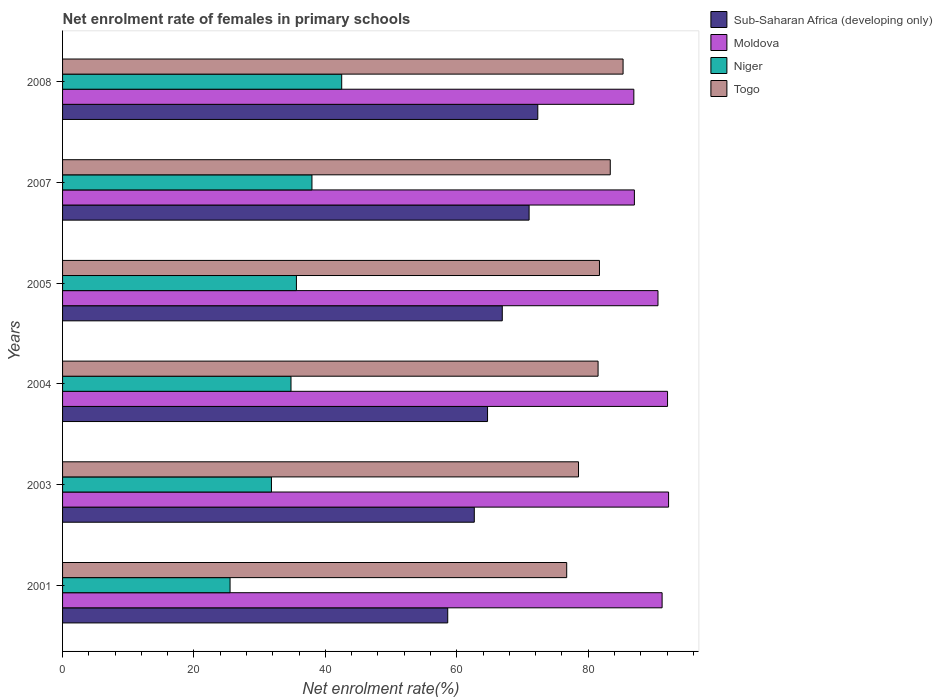How many different coloured bars are there?
Your answer should be compact. 4. Are the number of bars per tick equal to the number of legend labels?
Ensure brevity in your answer.  Yes. How many bars are there on the 1st tick from the bottom?
Your answer should be very brief. 4. In how many cases, is the number of bars for a given year not equal to the number of legend labels?
Offer a very short reply. 0. What is the net enrolment rate of females in primary schools in Togo in 2003?
Offer a terse response. 78.53. Across all years, what is the maximum net enrolment rate of females in primary schools in Togo?
Offer a very short reply. 85.31. Across all years, what is the minimum net enrolment rate of females in primary schools in Niger?
Keep it short and to the point. 25.49. In which year was the net enrolment rate of females in primary schools in Niger minimum?
Your answer should be compact. 2001. What is the total net enrolment rate of females in primary schools in Sub-Saharan Africa (developing only) in the graph?
Provide a succinct answer. 396.22. What is the difference between the net enrolment rate of females in primary schools in Sub-Saharan Africa (developing only) in 2003 and that in 2007?
Your answer should be very brief. -8.34. What is the difference between the net enrolment rate of females in primary schools in Moldova in 2004 and the net enrolment rate of females in primary schools in Togo in 2005?
Provide a short and direct response. 10.36. What is the average net enrolment rate of females in primary schools in Niger per year?
Your response must be concise. 34.68. In the year 2003, what is the difference between the net enrolment rate of females in primary schools in Moldova and net enrolment rate of females in primary schools in Niger?
Your response must be concise. 60.44. What is the ratio of the net enrolment rate of females in primary schools in Niger in 2001 to that in 2003?
Provide a short and direct response. 0.8. Is the net enrolment rate of females in primary schools in Moldova in 2001 less than that in 2008?
Offer a very short reply. No. What is the difference between the highest and the second highest net enrolment rate of females in primary schools in Togo?
Offer a terse response. 1.95. What is the difference between the highest and the lowest net enrolment rate of females in primary schools in Moldova?
Keep it short and to the point. 5.29. Is it the case that in every year, the sum of the net enrolment rate of females in primary schools in Togo and net enrolment rate of females in primary schools in Moldova is greater than the sum of net enrolment rate of females in primary schools in Sub-Saharan Africa (developing only) and net enrolment rate of females in primary schools in Niger?
Offer a terse response. Yes. What does the 2nd bar from the top in 2008 represents?
Ensure brevity in your answer.  Niger. What does the 4th bar from the bottom in 2004 represents?
Offer a very short reply. Togo. How many bars are there?
Your response must be concise. 24. What is the difference between two consecutive major ticks on the X-axis?
Keep it short and to the point. 20. What is the title of the graph?
Your answer should be compact. Net enrolment rate of females in primary schools. Does "Puerto Rico" appear as one of the legend labels in the graph?
Your answer should be very brief. No. What is the label or title of the X-axis?
Your answer should be compact. Net enrolment rate(%). What is the Net enrolment rate(%) in Sub-Saharan Africa (developing only) in 2001?
Your answer should be compact. 58.62. What is the Net enrolment rate(%) of Moldova in 2001?
Your response must be concise. 91.25. What is the Net enrolment rate(%) in Niger in 2001?
Ensure brevity in your answer.  25.49. What is the Net enrolment rate(%) in Togo in 2001?
Offer a very short reply. 76.73. What is the Net enrolment rate(%) of Sub-Saharan Africa (developing only) in 2003?
Your response must be concise. 62.66. What is the Net enrolment rate(%) of Moldova in 2003?
Ensure brevity in your answer.  92.23. What is the Net enrolment rate(%) of Niger in 2003?
Give a very brief answer. 31.79. What is the Net enrolment rate(%) of Togo in 2003?
Offer a terse response. 78.53. What is the Net enrolment rate(%) in Sub-Saharan Africa (developing only) in 2004?
Your response must be concise. 64.68. What is the Net enrolment rate(%) of Moldova in 2004?
Keep it short and to the point. 92.08. What is the Net enrolment rate(%) of Niger in 2004?
Keep it short and to the point. 34.77. What is the Net enrolment rate(%) in Togo in 2004?
Provide a succinct answer. 81.5. What is the Net enrolment rate(%) in Sub-Saharan Africa (developing only) in 2005?
Provide a short and direct response. 66.92. What is the Net enrolment rate(%) in Moldova in 2005?
Your answer should be very brief. 90.62. What is the Net enrolment rate(%) of Niger in 2005?
Keep it short and to the point. 35.59. What is the Net enrolment rate(%) in Togo in 2005?
Your answer should be compact. 81.71. What is the Net enrolment rate(%) in Sub-Saharan Africa (developing only) in 2007?
Give a very brief answer. 71.01. What is the Net enrolment rate(%) of Moldova in 2007?
Offer a terse response. 87.03. What is the Net enrolment rate(%) in Niger in 2007?
Your answer should be very brief. 37.96. What is the Net enrolment rate(%) of Togo in 2007?
Provide a short and direct response. 83.36. What is the Net enrolment rate(%) of Sub-Saharan Africa (developing only) in 2008?
Provide a short and direct response. 72.33. What is the Net enrolment rate(%) in Moldova in 2008?
Provide a succinct answer. 86.95. What is the Net enrolment rate(%) of Niger in 2008?
Your response must be concise. 42.48. What is the Net enrolment rate(%) in Togo in 2008?
Provide a succinct answer. 85.31. Across all years, what is the maximum Net enrolment rate(%) in Sub-Saharan Africa (developing only)?
Your answer should be compact. 72.33. Across all years, what is the maximum Net enrolment rate(%) of Moldova?
Ensure brevity in your answer.  92.23. Across all years, what is the maximum Net enrolment rate(%) of Niger?
Make the answer very short. 42.48. Across all years, what is the maximum Net enrolment rate(%) of Togo?
Offer a very short reply. 85.31. Across all years, what is the minimum Net enrolment rate(%) in Sub-Saharan Africa (developing only)?
Your answer should be compact. 58.62. Across all years, what is the minimum Net enrolment rate(%) in Moldova?
Offer a terse response. 86.95. Across all years, what is the minimum Net enrolment rate(%) in Niger?
Provide a succinct answer. 25.49. Across all years, what is the minimum Net enrolment rate(%) of Togo?
Offer a terse response. 76.73. What is the total Net enrolment rate(%) in Sub-Saharan Africa (developing only) in the graph?
Provide a succinct answer. 396.22. What is the total Net enrolment rate(%) of Moldova in the graph?
Offer a very short reply. 540.16. What is the total Net enrolment rate(%) of Niger in the graph?
Offer a terse response. 208.08. What is the total Net enrolment rate(%) in Togo in the graph?
Make the answer very short. 487.14. What is the difference between the Net enrolment rate(%) of Sub-Saharan Africa (developing only) in 2001 and that in 2003?
Provide a succinct answer. -4.04. What is the difference between the Net enrolment rate(%) in Moldova in 2001 and that in 2003?
Your answer should be very brief. -0.99. What is the difference between the Net enrolment rate(%) of Niger in 2001 and that in 2003?
Make the answer very short. -6.3. What is the difference between the Net enrolment rate(%) of Togo in 2001 and that in 2003?
Offer a terse response. -1.8. What is the difference between the Net enrolment rate(%) in Sub-Saharan Africa (developing only) in 2001 and that in 2004?
Offer a very short reply. -6.06. What is the difference between the Net enrolment rate(%) in Moldova in 2001 and that in 2004?
Keep it short and to the point. -0.83. What is the difference between the Net enrolment rate(%) of Niger in 2001 and that in 2004?
Your answer should be very brief. -9.27. What is the difference between the Net enrolment rate(%) in Togo in 2001 and that in 2004?
Keep it short and to the point. -4.78. What is the difference between the Net enrolment rate(%) in Sub-Saharan Africa (developing only) in 2001 and that in 2005?
Your answer should be compact. -8.3. What is the difference between the Net enrolment rate(%) in Moldova in 2001 and that in 2005?
Keep it short and to the point. 0.63. What is the difference between the Net enrolment rate(%) in Niger in 2001 and that in 2005?
Your answer should be very brief. -10.1. What is the difference between the Net enrolment rate(%) in Togo in 2001 and that in 2005?
Your response must be concise. -4.99. What is the difference between the Net enrolment rate(%) in Sub-Saharan Africa (developing only) in 2001 and that in 2007?
Keep it short and to the point. -12.38. What is the difference between the Net enrolment rate(%) of Moldova in 2001 and that in 2007?
Your answer should be compact. 4.22. What is the difference between the Net enrolment rate(%) of Niger in 2001 and that in 2007?
Offer a very short reply. -12.46. What is the difference between the Net enrolment rate(%) of Togo in 2001 and that in 2007?
Ensure brevity in your answer.  -6.63. What is the difference between the Net enrolment rate(%) of Sub-Saharan Africa (developing only) in 2001 and that in 2008?
Your response must be concise. -13.71. What is the difference between the Net enrolment rate(%) of Moldova in 2001 and that in 2008?
Provide a succinct answer. 4.3. What is the difference between the Net enrolment rate(%) of Niger in 2001 and that in 2008?
Offer a very short reply. -16.99. What is the difference between the Net enrolment rate(%) of Togo in 2001 and that in 2008?
Offer a terse response. -8.58. What is the difference between the Net enrolment rate(%) of Sub-Saharan Africa (developing only) in 2003 and that in 2004?
Offer a very short reply. -2.02. What is the difference between the Net enrolment rate(%) in Moldova in 2003 and that in 2004?
Your response must be concise. 0.16. What is the difference between the Net enrolment rate(%) of Niger in 2003 and that in 2004?
Provide a short and direct response. -2.98. What is the difference between the Net enrolment rate(%) in Togo in 2003 and that in 2004?
Give a very brief answer. -2.98. What is the difference between the Net enrolment rate(%) of Sub-Saharan Africa (developing only) in 2003 and that in 2005?
Offer a very short reply. -4.26. What is the difference between the Net enrolment rate(%) in Moldova in 2003 and that in 2005?
Offer a very short reply. 1.61. What is the difference between the Net enrolment rate(%) in Niger in 2003 and that in 2005?
Your answer should be compact. -3.8. What is the difference between the Net enrolment rate(%) of Togo in 2003 and that in 2005?
Ensure brevity in your answer.  -3.19. What is the difference between the Net enrolment rate(%) in Sub-Saharan Africa (developing only) in 2003 and that in 2007?
Offer a terse response. -8.34. What is the difference between the Net enrolment rate(%) of Moldova in 2003 and that in 2007?
Provide a short and direct response. 5.2. What is the difference between the Net enrolment rate(%) of Niger in 2003 and that in 2007?
Ensure brevity in your answer.  -6.17. What is the difference between the Net enrolment rate(%) of Togo in 2003 and that in 2007?
Ensure brevity in your answer.  -4.83. What is the difference between the Net enrolment rate(%) in Sub-Saharan Africa (developing only) in 2003 and that in 2008?
Make the answer very short. -9.66. What is the difference between the Net enrolment rate(%) in Moldova in 2003 and that in 2008?
Keep it short and to the point. 5.29. What is the difference between the Net enrolment rate(%) of Niger in 2003 and that in 2008?
Your answer should be compact. -10.69. What is the difference between the Net enrolment rate(%) in Togo in 2003 and that in 2008?
Make the answer very short. -6.78. What is the difference between the Net enrolment rate(%) in Sub-Saharan Africa (developing only) in 2004 and that in 2005?
Offer a very short reply. -2.24. What is the difference between the Net enrolment rate(%) in Moldova in 2004 and that in 2005?
Your answer should be compact. 1.45. What is the difference between the Net enrolment rate(%) of Niger in 2004 and that in 2005?
Your answer should be very brief. -0.82. What is the difference between the Net enrolment rate(%) in Togo in 2004 and that in 2005?
Offer a very short reply. -0.21. What is the difference between the Net enrolment rate(%) of Sub-Saharan Africa (developing only) in 2004 and that in 2007?
Ensure brevity in your answer.  -6.33. What is the difference between the Net enrolment rate(%) in Moldova in 2004 and that in 2007?
Keep it short and to the point. 5.05. What is the difference between the Net enrolment rate(%) of Niger in 2004 and that in 2007?
Make the answer very short. -3.19. What is the difference between the Net enrolment rate(%) of Togo in 2004 and that in 2007?
Make the answer very short. -1.85. What is the difference between the Net enrolment rate(%) of Sub-Saharan Africa (developing only) in 2004 and that in 2008?
Your answer should be compact. -7.65. What is the difference between the Net enrolment rate(%) in Moldova in 2004 and that in 2008?
Ensure brevity in your answer.  5.13. What is the difference between the Net enrolment rate(%) in Niger in 2004 and that in 2008?
Provide a short and direct response. -7.72. What is the difference between the Net enrolment rate(%) of Togo in 2004 and that in 2008?
Keep it short and to the point. -3.8. What is the difference between the Net enrolment rate(%) of Sub-Saharan Africa (developing only) in 2005 and that in 2007?
Provide a short and direct response. -4.08. What is the difference between the Net enrolment rate(%) in Moldova in 2005 and that in 2007?
Offer a very short reply. 3.59. What is the difference between the Net enrolment rate(%) of Niger in 2005 and that in 2007?
Provide a succinct answer. -2.37. What is the difference between the Net enrolment rate(%) of Togo in 2005 and that in 2007?
Ensure brevity in your answer.  -1.64. What is the difference between the Net enrolment rate(%) of Sub-Saharan Africa (developing only) in 2005 and that in 2008?
Ensure brevity in your answer.  -5.41. What is the difference between the Net enrolment rate(%) of Moldova in 2005 and that in 2008?
Give a very brief answer. 3.68. What is the difference between the Net enrolment rate(%) in Niger in 2005 and that in 2008?
Provide a short and direct response. -6.89. What is the difference between the Net enrolment rate(%) in Togo in 2005 and that in 2008?
Your answer should be very brief. -3.59. What is the difference between the Net enrolment rate(%) of Sub-Saharan Africa (developing only) in 2007 and that in 2008?
Provide a succinct answer. -1.32. What is the difference between the Net enrolment rate(%) of Moldova in 2007 and that in 2008?
Your answer should be compact. 0.08. What is the difference between the Net enrolment rate(%) of Niger in 2007 and that in 2008?
Make the answer very short. -4.53. What is the difference between the Net enrolment rate(%) in Togo in 2007 and that in 2008?
Ensure brevity in your answer.  -1.95. What is the difference between the Net enrolment rate(%) of Sub-Saharan Africa (developing only) in 2001 and the Net enrolment rate(%) of Moldova in 2003?
Your response must be concise. -33.61. What is the difference between the Net enrolment rate(%) of Sub-Saharan Africa (developing only) in 2001 and the Net enrolment rate(%) of Niger in 2003?
Provide a succinct answer. 26.83. What is the difference between the Net enrolment rate(%) of Sub-Saharan Africa (developing only) in 2001 and the Net enrolment rate(%) of Togo in 2003?
Your answer should be compact. -19.91. What is the difference between the Net enrolment rate(%) in Moldova in 2001 and the Net enrolment rate(%) in Niger in 2003?
Offer a terse response. 59.46. What is the difference between the Net enrolment rate(%) in Moldova in 2001 and the Net enrolment rate(%) in Togo in 2003?
Ensure brevity in your answer.  12.72. What is the difference between the Net enrolment rate(%) in Niger in 2001 and the Net enrolment rate(%) in Togo in 2003?
Give a very brief answer. -53.04. What is the difference between the Net enrolment rate(%) of Sub-Saharan Africa (developing only) in 2001 and the Net enrolment rate(%) of Moldova in 2004?
Provide a short and direct response. -33.45. What is the difference between the Net enrolment rate(%) in Sub-Saharan Africa (developing only) in 2001 and the Net enrolment rate(%) in Niger in 2004?
Provide a short and direct response. 23.86. What is the difference between the Net enrolment rate(%) in Sub-Saharan Africa (developing only) in 2001 and the Net enrolment rate(%) in Togo in 2004?
Your answer should be compact. -22.88. What is the difference between the Net enrolment rate(%) in Moldova in 2001 and the Net enrolment rate(%) in Niger in 2004?
Offer a terse response. 56.48. What is the difference between the Net enrolment rate(%) of Moldova in 2001 and the Net enrolment rate(%) of Togo in 2004?
Keep it short and to the point. 9.74. What is the difference between the Net enrolment rate(%) in Niger in 2001 and the Net enrolment rate(%) in Togo in 2004?
Your response must be concise. -56.01. What is the difference between the Net enrolment rate(%) in Sub-Saharan Africa (developing only) in 2001 and the Net enrolment rate(%) in Moldova in 2005?
Your answer should be compact. -32. What is the difference between the Net enrolment rate(%) of Sub-Saharan Africa (developing only) in 2001 and the Net enrolment rate(%) of Niger in 2005?
Provide a succinct answer. 23.03. What is the difference between the Net enrolment rate(%) of Sub-Saharan Africa (developing only) in 2001 and the Net enrolment rate(%) of Togo in 2005?
Your response must be concise. -23.09. What is the difference between the Net enrolment rate(%) of Moldova in 2001 and the Net enrolment rate(%) of Niger in 2005?
Keep it short and to the point. 55.66. What is the difference between the Net enrolment rate(%) of Moldova in 2001 and the Net enrolment rate(%) of Togo in 2005?
Offer a terse response. 9.53. What is the difference between the Net enrolment rate(%) of Niger in 2001 and the Net enrolment rate(%) of Togo in 2005?
Give a very brief answer. -56.22. What is the difference between the Net enrolment rate(%) in Sub-Saharan Africa (developing only) in 2001 and the Net enrolment rate(%) in Moldova in 2007?
Give a very brief answer. -28.41. What is the difference between the Net enrolment rate(%) in Sub-Saharan Africa (developing only) in 2001 and the Net enrolment rate(%) in Niger in 2007?
Your answer should be very brief. 20.67. What is the difference between the Net enrolment rate(%) of Sub-Saharan Africa (developing only) in 2001 and the Net enrolment rate(%) of Togo in 2007?
Offer a very short reply. -24.74. What is the difference between the Net enrolment rate(%) in Moldova in 2001 and the Net enrolment rate(%) in Niger in 2007?
Ensure brevity in your answer.  53.29. What is the difference between the Net enrolment rate(%) in Moldova in 2001 and the Net enrolment rate(%) in Togo in 2007?
Your answer should be very brief. 7.89. What is the difference between the Net enrolment rate(%) of Niger in 2001 and the Net enrolment rate(%) of Togo in 2007?
Ensure brevity in your answer.  -57.87. What is the difference between the Net enrolment rate(%) in Sub-Saharan Africa (developing only) in 2001 and the Net enrolment rate(%) in Moldova in 2008?
Your answer should be compact. -28.32. What is the difference between the Net enrolment rate(%) in Sub-Saharan Africa (developing only) in 2001 and the Net enrolment rate(%) in Niger in 2008?
Keep it short and to the point. 16.14. What is the difference between the Net enrolment rate(%) in Sub-Saharan Africa (developing only) in 2001 and the Net enrolment rate(%) in Togo in 2008?
Your response must be concise. -26.69. What is the difference between the Net enrolment rate(%) of Moldova in 2001 and the Net enrolment rate(%) of Niger in 2008?
Provide a succinct answer. 48.77. What is the difference between the Net enrolment rate(%) of Moldova in 2001 and the Net enrolment rate(%) of Togo in 2008?
Keep it short and to the point. 5.94. What is the difference between the Net enrolment rate(%) of Niger in 2001 and the Net enrolment rate(%) of Togo in 2008?
Offer a terse response. -59.82. What is the difference between the Net enrolment rate(%) in Sub-Saharan Africa (developing only) in 2003 and the Net enrolment rate(%) in Moldova in 2004?
Your response must be concise. -29.41. What is the difference between the Net enrolment rate(%) in Sub-Saharan Africa (developing only) in 2003 and the Net enrolment rate(%) in Niger in 2004?
Give a very brief answer. 27.9. What is the difference between the Net enrolment rate(%) of Sub-Saharan Africa (developing only) in 2003 and the Net enrolment rate(%) of Togo in 2004?
Your answer should be compact. -18.84. What is the difference between the Net enrolment rate(%) of Moldova in 2003 and the Net enrolment rate(%) of Niger in 2004?
Give a very brief answer. 57.47. What is the difference between the Net enrolment rate(%) in Moldova in 2003 and the Net enrolment rate(%) in Togo in 2004?
Offer a terse response. 10.73. What is the difference between the Net enrolment rate(%) of Niger in 2003 and the Net enrolment rate(%) of Togo in 2004?
Your response must be concise. -49.71. What is the difference between the Net enrolment rate(%) of Sub-Saharan Africa (developing only) in 2003 and the Net enrolment rate(%) of Moldova in 2005?
Offer a terse response. -27.96. What is the difference between the Net enrolment rate(%) of Sub-Saharan Africa (developing only) in 2003 and the Net enrolment rate(%) of Niger in 2005?
Offer a very short reply. 27.07. What is the difference between the Net enrolment rate(%) of Sub-Saharan Africa (developing only) in 2003 and the Net enrolment rate(%) of Togo in 2005?
Keep it short and to the point. -19.05. What is the difference between the Net enrolment rate(%) of Moldova in 2003 and the Net enrolment rate(%) of Niger in 2005?
Your response must be concise. 56.64. What is the difference between the Net enrolment rate(%) in Moldova in 2003 and the Net enrolment rate(%) in Togo in 2005?
Ensure brevity in your answer.  10.52. What is the difference between the Net enrolment rate(%) of Niger in 2003 and the Net enrolment rate(%) of Togo in 2005?
Provide a succinct answer. -49.92. What is the difference between the Net enrolment rate(%) of Sub-Saharan Africa (developing only) in 2003 and the Net enrolment rate(%) of Moldova in 2007?
Ensure brevity in your answer.  -24.37. What is the difference between the Net enrolment rate(%) of Sub-Saharan Africa (developing only) in 2003 and the Net enrolment rate(%) of Niger in 2007?
Offer a very short reply. 24.71. What is the difference between the Net enrolment rate(%) of Sub-Saharan Africa (developing only) in 2003 and the Net enrolment rate(%) of Togo in 2007?
Your response must be concise. -20.69. What is the difference between the Net enrolment rate(%) in Moldova in 2003 and the Net enrolment rate(%) in Niger in 2007?
Make the answer very short. 54.28. What is the difference between the Net enrolment rate(%) of Moldova in 2003 and the Net enrolment rate(%) of Togo in 2007?
Your response must be concise. 8.88. What is the difference between the Net enrolment rate(%) of Niger in 2003 and the Net enrolment rate(%) of Togo in 2007?
Ensure brevity in your answer.  -51.57. What is the difference between the Net enrolment rate(%) of Sub-Saharan Africa (developing only) in 2003 and the Net enrolment rate(%) of Moldova in 2008?
Offer a very short reply. -24.28. What is the difference between the Net enrolment rate(%) of Sub-Saharan Africa (developing only) in 2003 and the Net enrolment rate(%) of Niger in 2008?
Keep it short and to the point. 20.18. What is the difference between the Net enrolment rate(%) in Sub-Saharan Africa (developing only) in 2003 and the Net enrolment rate(%) in Togo in 2008?
Make the answer very short. -22.64. What is the difference between the Net enrolment rate(%) in Moldova in 2003 and the Net enrolment rate(%) in Niger in 2008?
Give a very brief answer. 49.75. What is the difference between the Net enrolment rate(%) of Moldova in 2003 and the Net enrolment rate(%) of Togo in 2008?
Your answer should be compact. 6.93. What is the difference between the Net enrolment rate(%) of Niger in 2003 and the Net enrolment rate(%) of Togo in 2008?
Provide a succinct answer. -53.52. What is the difference between the Net enrolment rate(%) of Sub-Saharan Africa (developing only) in 2004 and the Net enrolment rate(%) of Moldova in 2005?
Give a very brief answer. -25.94. What is the difference between the Net enrolment rate(%) of Sub-Saharan Africa (developing only) in 2004 and the Net enrolment rate(%) of Niger in 2005?
Make the answer very short. 29.09. What is the difference between the Net enrolment rate(%) in Sub-Saharan Africa (developing only) in 2004 and the Net enrolment rate(%) in Togo in 2005?
Your response must be concise. -17.03. What is the difference between the Net enrolment rate(%) in Moldova in 2004 and the Net enrolment rate(%) in Niger in 2005?
Offer a terse response. 56.48. What is the difference between the Net enrolment rate(%) of Moldova in 2004 and the Net enrolment rate(%) of Togo in 2005?
Provide a short and direct response. 10.36. What is the difference between the Net enrolment rate(%) in Niger in 2004 and the Net enrolment rate(%) in Togo in 2005?
Your answer should be compact. -46.95. What is the difference between the Net enrolment rate(%) in Sub-Saharan Africa (developing only) in 2004 and the Net enrolment rate(%) in Moldova in 2007?
Make the answer very short. -22.35. What is the difference between the Net enrolment rate(%) of Sub-Saharan Africa (developing only) in 2004 and the Net enrolment rate(%) of Niger in 2007?
Offer a terse response. 26.72. What is the difference between the Net enrolment rate(%) of Sub-Saharan Africa (developing only) in 2004 and the Net enrolment rate(%) of Togo in 2007?
Make the answer very short. -18.68. What is the difference between the Net enrolment rate(%) of Moldova in 2004 and the Net enrolment rate(%) of Niger in 2007?
Your answer should be very brief. 54.12. What is the difference between the Net enrolment rate(%) in Moldova in 2004 and the Net enrolment rate(%) in Togo in 2007?
Your answer should be compact. 8.72. What is the difference between the Net enrolment rate(%) of Niger in 2004 and the Net enrolment rate(%) of Togo in 2007?
Ensure brevity in your answer.  -48.59. What is the difference between the Net enrolment rate(%) of Sub-Saharan Africa (developing only) in 2004 and the Net enrolment rate(%) of Moldova in 2008?
Your response must be concise. -22.27. What is the difference between the Net enrolment rate(%) of Sub-Saharan Africa (developing only) in 2004 and the Net enrolment rate(%) of Niger in 2008?
Ensure brevity in your answer.  22.2. What is the difference between the Net enrolment rate(%) of Sub-Saharan Africa (developing only) in 2004 and the Net enrolment rate(%) of Togo in 2008?
Your response must be concise. -20.63. What is the difference between the Net enrolment rate(%) in Moldova in 2004 and the Net enrolment rate(%) in Niger in 2008?
Keep it short and to the point. 49.59. What is the difference between the Net enrolment rate(%) of Moldova in 2004 and the Net enrolment rate(%) of Togo in 2008?
Your response must be concise. 6.77. What is the difference between the Net enrolment rate(%) in Niger in 2004 and the Net enrolment rate(%) in Togo in 2008?
Your answer should be compact. -50.54. What is the difference between the Net enrolment rate(%) of Sub-Saharan Africa (developing only) in 2005 and the Net enrolment rate(%) of Moldova in 2007?
Give a very brief answer. -20.11. What is the difference between the Net enrolment rate(%) in Sub-Saharan Africa (developing only) in 2005 and the Net enrolment rate(%) in Niger in 2007?
Give a very brief answer. 28.97. What is the difference between the Net enrolment rate(%) of Sub-Saharan Africa (developing only) in 2005 and the Net enrolment rate(%) of Togo in 2007?
Your response must be concise. -16.44. What is the difference between the Net enrolment rate(%) of Moldova in 2005 and the Net enrolment rate(%) of Niger in 2007?
Provide a short and direct response. 52.66. What is the difference between the Net enrolment rate(%) in Moldova in 2005 and the Net enrolment rate(%) in Togo in 2007?
Your answer should be compact. 7.26. What is the difference between the Net enrolment rate(%) of Niger in 2005 and the Net enrolment rate(%) of Togo in 2007?
Provide a short and direct response. -47.77. What is the difference between the Net enrolment rate(%) in Sub-Saharan Africa (developing only) in 2005 and the Net enrolment rate(%) in Moldova in 2008?
Your answer should be compact. -20.02. What is the difference between the Net enrolment rate(%) in Sub-Saharan Africa (developing only) in 2005 and the Net enrolment rate(%) in Niger in 2008?
Make the answer very short. 24.44. What is the difference between the Net enrolment rate(%) of Sub-Saharan Africa (developing only) in 2005 and the Net enrolment rate(%) of Togo in 2008?
Make the answer very short. -18.39. What is the difference between the Net enrolment rate(%) in Moldova in 2005 and the Net enrolment rate(%) in Niger in 2008?
Make the answer very short. 48.14. What is the difference between the Net enrolment rate(%) of Moldova in 2005 and the Net enrolment rate(%) of Togo in 2008?
Offer a very short reply. 5.31. What is the difference between the Net enrolment rate(%) of Niger in 2005 and the Net enrolment rate(%) of Togo in 2008?
Offer a very short reply. -49.72. What is the difference between the Net enrolment rate(%) of Sub-Saharan Africa (developing only) in 2007 and the Net enrolment rate(%) of Moldova in 2008?
Keep it short and to the point. -15.94. What is the difference between the Net enrolment rate(%) in Sub-Saharan Africa (developing only) in 2007 and the Net enrolment rate(%) in Niger in 2008?
Your answer should be compact. 28.52. What is the difference between the Net enrolment rate(%) in Sub-Saharan Africa (developing only) in 2007 and the Net enrolment rate(%) in Togo in 2008?
Offer a very short reply. -14.3. What is the difference between the Net enrolment rate(%) in Moldova in 2007 and the Net enrolment rate(%) in Niger in 2008?
Ensure brevity in your answer.  44.55. What is the difference between the Net enrolment rate(%) in Moldova in 2007 and the Net enrolment rate(%) in Togo in 2008?
Give a very brief answer. 1.72. What is the difference between the Net enrolment rate(%) in Niger in 2007 and the Net enrolment rate(%) in Togo in 2008?
Provide a succinct answer. -47.35. What is the average Net enrolment rate(%) in Sub-Saharan Africa (developing only) per year?
Your response must be concise. 66.04. What is the average Net enrolment rate(%) in Moldova per year?
Give a very brief answer. 90.03. What is the average Net enrolment rate(%) in Niger per year?
Provide a succinct answer. 34.68. What is the average Net enrolment rate(%) of Togo per year?
Make the answer very short. 81.19. In the year 2001, what is the difference between the Net enrolment rate(%) of Sub-Saharan Africa (developing only) and Net enrolment rate(%) of Moldova?
Offer a terse response. -32.63. In the year 2001, what is the difference between the Net enrolment rate(%) in Sub-Saharan Africa (developing only) and Net enrolment rate(%) in Niger?
Provide a short and direct response. 33.13. In the year 2001, what is the difference between the Net enrolment rate(%) of Sub-Saharan Africa (developing only) and Net enrolment rate(%) of Togo?
Keep it short and to the point. -18.11. In the year 2001, what is the difference between the Net enrolment rate(%) in Moldova and Net enrolment rate(%) in Niger?
Provide a short and direct response. 65.76. In the year 2001, what is the difference between the Net enrolment rate(%) of Moldova and Net enrolment rate(%) of Togo?
Offer a terse response. 14.52. In the year 2001, what is the difference between the Net enrolment rate(%) in Niger and Net enrolment rate(%) in Togo?
Offer a very short reply. -51.24. In the year 2003, what is the difference between the Net enrolment rate(%) in Sub-Saharan Africa (developing only) and Net enrolment rate(%) in Moldova?
Provide a short and direct response. -29.57. In the year 2003, what is the difference between the Net enrolment rate(%) of Sub-Saharan Africa (developing only) and Net enrolment rate(%) of Niger?
Offer a terse response. 30.87. In the year 2003, what is the difference between the Net enrolment rate(%) in Sub-Saharan Africa (developing only) and Net enrolment rate(%) in Togo?
Keep it short and to the point. -15.86. In the year 2003, what is the difference between the Net enrolment rate(%) of Moldova and Net enrolment rate(%) of Niger?
Offer a terse response. 60.44. In the year 2003, what is the difference between the Net enrolment rate(%) of Moldova and Net enrolment rate(%) of Togo?
Keep it short and to the point. 13.71. In the year 2003, what is the difference between the Net enrolment rate(%) of Niger and Net enrolment rate(%) of Togo?
Make the answer very short. -46.74. In the year 2004, what is the difference between the Net enrolment rate(%) in Sub-Saharan Africa (developing only) and Net enrolment rate(%) in Moldova?
Provide a short and direct response. -27.4. In the year 2004, what is the difference between the Net enrolment rate(%) in Sub-Saharan Africa (developing only) and Net enrolment rate(%) in Niger?
Provide a short and direct response. 29.91. In the year 2004, what is the difference between the Net enrolment rate(%) in Sub-Saharan Africa (developing only) and Net enrolment rate(%) in Togo?
Keep it short and to the point. -16.82. In the year 2004, what is the difference between the Net enrolment rate(%) in Moldova and Net enrolment rate(%) in Niger?
Your response must be concise. 57.31. In the year 2004, what is the difference between the Net enrolment rate(%) in Moldova and Net enrolment rate(%) in Togo?
Offer a terse response. 10.57. In the year 2004, what is the difference between the Net enrolment rate(%) of Niger and Net enrolment rate(%) of Togo?
Your answer should be compact. -46.74. In the year 2005, what is the difference between the Net enrolment rate(%) in Sub-Saharan Africa (developing only) and Net enrolment rate(%) in Moldova?
Your answer should be very brief. -23.7. In the year 2005, what is the difference between the Net enrolment rate(%) of Sub-Saharan Africa (developing only) and Net enrolment rate(%) of Niger?
Your response must be concise. 31.33. In the year 2005, what is the difference between the Net enrolment rate(%) of Sub-Saharan Africa (developing only) and Net enrolment rate(%) of Togo?
Give a very brief answer. -14.79. In the year 2005, what is the difference between the Net enrolment rate(%) of Moldova and Net enrolment rate(%) of Niger?
Offer a very short reply. 55.03. In the year 2005, what is the difference between the Net enrolment rate(%) of Moldova and Net enrolment rate(%) of Togo?
Give a very brief answer. 8.91. In the year 2005, what is the difference between the Net enrolment rate(%) in Niger and Net enrolment rate(%) in Togo?
Your answer should be very brief. -46.12. In the year 2007, what is the difference between the Net enrolment rate(%) of Sub-Saharan Africa (developing only) and Net enrolment rate(%) of Moldova?
Give a very brief answer. -16.02. In the year 2007, what is the difference between the Net enrolment rate(%) of Sub-Saharan Africa (developing only) and Net enrolment rate(%) of Niger?
Your answer should be very brief. 33.05. In the year 2007, what is the difference between the Net enrolment rate(%) of Sub-Saharan Africa (developing only) and Net enrolment rate(%) of Togo?
Ensure brevity in your answer.  -12.35. In the year 2007, what is the difference between the Net enrolment rate(%) in Moldova and Net enrolment rate(%) in Niger?
Your response must be concise. 49.07. In the year 2007, what is the difference between the Net enrolment rate(%) of Moldova and Net enrolment rate(%) of Togo?
Provide a short and direct response. 3.67. In the year 2007, what is the difference between the Net enrolment rate(%) in Niger and Net enrolment rate(%) in Togo?
Your response must be concise. -45.4. In the year 2008, what is the difference between the Net enrolment rate(%) of Sub-Saharan Africa (developing only) and Net enrolment rate(%) of Moldova?
Offer a very short reply. -14.62. In the year 2008, what is the difference between the Net enrolment rate(%) of Sub-Saharan Africa (developing only) and Net enrolment rate(%) of Niger?
Provide a short and direct response. 29.85. In the year 2008, what is the difference between the Net enrolment rate(%) of Sub-Saharan Africa (developing only) and Net enrolment rate(%) of Togo?
Your answer should be very brief. -12.98. In the year 2008, what is the difference between the Net enrolment rate(%) in Moldova and Net enrolment rate(%) in Niger?
Provide a succinct answer. 44.46. In the year 2008, what is the difference between the Net enrolment rate(%) in Moldova and Net enrolment rate(%) in Togo?
Make the answer very short. 1.64. In the year 2008, what is the difference between the Net enrolment rate(%) of Niger and Net enrolment rate(%) of Togo?
Make the answer very short. -42.82. What is the ratio of the Net enrolment rate(%) in Sub-Saharan Africa (developing only) in 2001 to that in 2003?
Offer a terse response. 0.94. What is the ratio of the Net enrolment rate(%) of Moldova in 2001 to that in 2003?
Provide a succinct answer. 0.99. What is the ratio of the Net enrolment rate(%) in Niger in 2001 to that in 2003?
Keep it short and to the point. 0.8. What is the ratio of the Net enrolment rate(%) of Togo in 2001 to that in 2003?
Keep it short and to the point. 0.98. What is the ratio of the Net enrolment rate(%) of Sub-Saharan Africa (developing only) in 2001 to that in 2004?
Offer a terse response. 0.91. What is the ratio of the Net enrolment rate(%) in Moldova in 2001 to that in 2004?
Keep it short and to the point. 0.99. What is the ratio of the Net enrolment rate(%) of Niger in 2001 to that in 2004?
Your response must be concise. 0.73. What is the ratio of the Net enrolment rate(%) in Togo in 2001 to that in 2004?
Make the answer very short. 0.94. What is the ratio of the Net enrolment rate(%) of Sub-Saharan Africa (developing only) in 2001 to that in 2005?
Make the answer very short. 0.88. What is the ratio of the Net enrolment rate(%) of Moldova in 2001 to that in 2005?
Make the answer very short. 1.01. What is the ratio of the Net enrolment rate(%) in Niger in 2001 to that in 2005?
Give a very brief answer. 0.72. What is the ratio of the Net enrolment rate(%) in Togo in 2001 to that in 2005?
Your answer should be compact. 0.94. What is the ratio of the Net enrolment rate(%) in Sub-Saharan Africa (developing only) in 2001 to that in 2007?
Give a very brief answer. 0.83. What is the ratio of the Net enrolment rate(%) in Moldova in 2001 to that in 2007?
Offer a very short reply. 1.05. What is the ratio of the Net enrolment rate(%) in Niger in 2001 to that in 2007?
Provide a short and direct response. 0.67. What is the ratio of the Net enrolment rate(%) in Togo in 2001 to that in 2007?
Keep it short and to the point. 0.92. What is the ratio of the Net enrolment rate(%) of Sub-Saharan Africa (developing only) in 2001 to that in 2008?
Ensure brevity in your answer.  0.81. What is the ratio of the Net enrolment rate(%) of Moldova in 2001 to that in 2008?
Provide a short and direct response. 1.05. What is the ratio of the Net enrolment rate(%) in Niger in 2001 to that in 2008?
Provide a short and direct response. 0.6. What is the ratio of the Net enrolment rate(%) in Togo in 2001 to that in 2008?
Provide a succinct answer. 0.9. What is the ratio of the Net enrolment rate(%) in Sub-Saharan Africa (developing only) in 2003 to that in 2004?
Make the answer very short. 0.97. What is the ratio of the Net enrolment rate(%) of Moldova in 2003 to that in 2004?
Give a very brief answer. 1. What is the ratio of the Net enrolment rate(%) of Niger in 2003 to that in 2004?
Your answer should be compact. 0.91. What is the ratio of the Net enrolment rate(%) of Togo in 2003 to that in 2004?
Provide a short and direct response. 0.96. What is the ratio of the Net enrolment rate(%) in Sub-Saharan Africa (developing only) in 2003 to that in 2005?
Your answer should be very brief. 0.94. What is the ratio of the Net enrolment rate(%) of Moldova in 2003 to that in 2005?
Provide a succinct answer. 1.02. What is the ratio of the Net enrolment rate(%) of Niger in 2003 to that in 2005?
Provide a succinct answer. 0.89. What is the ratio of the Net enrolment rate(%) in Sub-Saharan Africa (developing only) in 2003 to that in 2007?
Keep it short and to the point. 0.88. What is the ratio of the Net enrolment rate(%) of Moldova in 2003 to that in 2007?
Provide a succinct answer. 1.06. What is the ratio of the Net enrolment rate(%) of Niger in 2003 to that in 2007?
Offer a terse response. 0.84. What is the ratio of the Net enrolment rate(%) of Togo in 2003 to that in 2007?
Ensure brevity in your answer.  0.94. What is the ratio of the Net enrolment rate(%) in Sub-Saharan Africa (developing only) in 2003 to that in 2008?
Give a very brief answer. 0.87. What is the ratio of the Net enrolment rate(%) in Moldova in 2003 to that in 2008?
Provide a short and direct response. 1.06. What is the ratio of the Net enrolment rate(%) in Niger in 2003 to that in 2008?
Your answer should be compact. 0.75. What is the ratio of the Net enrolment rate(%) in Togo in 2003 to that in 2008?
Give a very brief answer. 0.92. What is the ratio of the Net enrolment rate(%) in Sub-Saharan Africa (developing only) in 2004 to that in 2005?
Keep it short and to the point. 0.97. What is the ratio of the Net enrolment rate(%) of Moldova in 2004 to that in 2005?
Provide a short and direct response. 1.02. What is the ratio of the Net enrolment rate(%) in Niger in 2004 to that in 2005?
Keep it short and to the point. 0.98. What is the ratio of the Net enrolment rate(%) in Togo in 2004 to that in 2005?
Your response must be concise. 1. What is the ratio of the Net enrolment rate(%) of Sub-Saharan Africa (developing only) in 2004 to that in 2007?
Provide a short and direct response. 0.91. What is the ratio of the Net enrolment rate(%) in Moldova in 2004 to that in 2007?
Offer a terse response. 1.06. What is the ratio of the Net enrolment rate(%) of Niger in 2004 to that in 2007?
Ensure brevity in your answer.  0.92. What is the ratio of the Net enrolment rate(%) of Togo in 2004 to that in 2007?
Provide a short and direct response. 0.98. What is the ratio of the Net enrolment rate(%) in Sub-Saharan Africa (developing only) in 2004 to that in 2008?
Your answer should be compact. 0.89. What is the ratio of the Net enrolment rate(%) in Moldova in 2004 to that in 2008?
Your answer should be very brief. 1.06. What is the ratio of the Net enrolment rate(%) of Niger in 2004 to that in 2008?
Your response must be concise. 0.82. What is the ratio of the Net enrolment rate(%) of Togo in 2004 to that in 2008?
Your answer should be very brief. 0.96. What is the ratio of the Net enrolment rate(%) of Sub-Saharan Africa (developing only) in 2005 to that in 2007?
Offer a very short reply. 0.94. What is the ratio of the Net enrolment rate(%) in Moldova in 2005 to that in 2007?
Keep it short and to the point. 1.04. What is the ratio of the Net enrolment rate(%) in Niger in 2005 to that in 2007?
Keep it short and to the point. 0.94. What is the ratio of the Net enrolment rate(%) in Togo in 2005 to that in 2007?
Offer a terse response. 0.98. What is the ratio of the Net enrolment rate(%) of Sub-Saharan Africa (developing only) in 2005 to that in 2008?
Provide a succinct answer. 0.93. What is the ratio of the Net enrolment rate(%) in Moldova in 2005 to that in 2008?
Provide a short and direct response. 1.04. What is the ratio of the Net enrolment rate(%) in Niger in 2005 to that in 2008?
Give a very brief answer. 0.84. What is the ratio of the Net enrolment rate(%) in Togo in 2005 to that in 2008?
Your response must be concise. 0.96. What is the ratio of the Net enrolment rate(%) of Sub-Saharan Africa (developing only) in 2007 to that in 2008?
Ensure brevity in your answer.  0.98. What is the ratio of the Net enrolment rate(%) of Moldova in 2007 to that in 2008?
Provide a succinct answer. 1. What is the ratio of the Net enrolment rate(%) of Niger in 2007 to that in 2008?
Your answer should be very brief. 0.89. What is the ratio of the Net enrolment rate(%) of Togo in 2007 to that in 2008?
Provide a succinct answer. 0.98. What is the difference between the highest and the second highest Net enrolment rate(%) of Sub-Saharan Africa (developing only)?
Your response must be concise. 1.32. What is the difference between the highest and the second highest Net enrolment rate(%) in Moldova?
Ensure brevity in your answer.  0.16. What is the difference between the highest and the second highest Net enrolment rate(%) in Niger?
Provide a succinct answer. 4.53. What is the difference between the highest and the second highest Net enrolment rate(%) of Togo?
Give a very brief answer. 1.95. What is the difference between the highest and the lowest Net enrolment rate(%) of Sub-Saharan Africa (developing only)?
Offer a terse response. 13.71. What is the difference between the highest and the lowest Net enrolment rate(%) in Moldova?
Your response must be concise. 5.29. What is the difference between the highest and the lowest Net enrolment rate(%) of Niger?
Your answer should be very brief. 16.99. What is the difference between the highest and the lowest Net enrolment rate(%) of Togo?
Give a very brief answer. 8.58. 